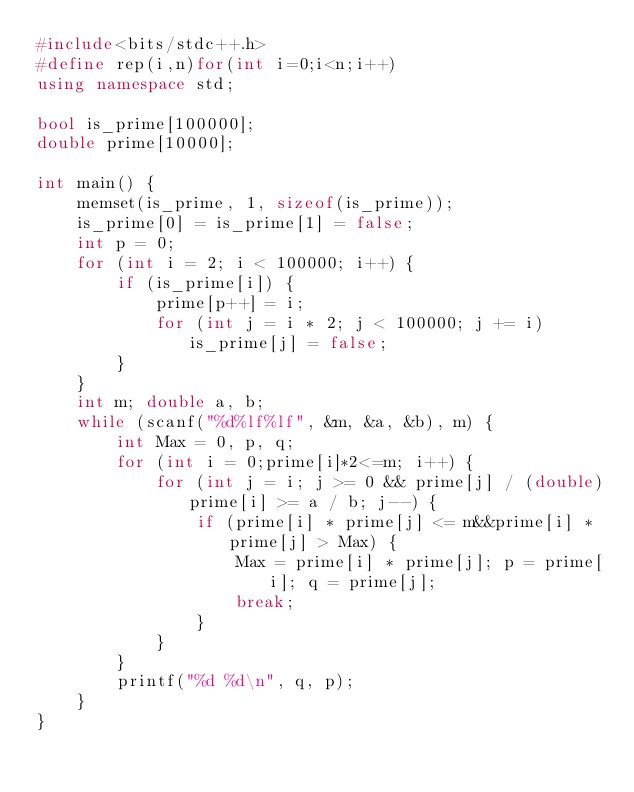Convert code to text. <code><loc_0><loc_0><loc_500><loc_500><_C++_>#include<bits/stdc++.h>
#define rep(i,n)for(int i=0;i<n;i++)
using namespace std;

bool is_prime[100000];
double prime[10000];

int main() {
	memset(is_prime, 1, sizeof(is_prime));
	is_prime[0] = is_prime[1] = false;
	int p = 0;
	for (int i = 2; i < 100000; i++) {
		if (is_prime[i]) {
			prime[p++] = i;
			for (int j = i * 2; j < 100000; j += i)is_prime[j] = false;
		}
	}
	int m; double a, b;
	while (scanf("%d%lf%lf", &m, &a, &b), m) {
		int Max = 0, p, q;
		for (int i = 0;prime[i]*2<=m; i++) {
			for (int j = i; j >= 0 && prime[j] / (double)prime[i] >= a / b; j--) {
				if (prime[i] * prime[j] <= m&&prime[i] * prime[j] > Max) {
					Max = prime[i] * prime[j]; p = prime[i]; q = prime[j];
					break;
				}
			}
		}
		printf("%d %d\n", q, p);
	}
}</code> 